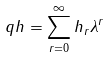Convert formula to latex. <formula><loc_0><loc_0><loc_500><loc_500>\ q h = \sum _ { r = 0 } ^ { \infty } h _ { r } \lambda ^ { r }</formula> 